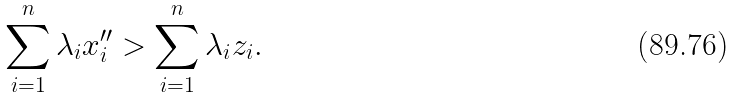<formula> <loc_0><loc_0><loc_500><loc_500>\sum _ { i = 1 } ^ { n } \lambda _ { i } x ^ { \prime \prime } _ { i } & > \sum _ { i = 1 } ^ { n } \lambda _ { i } z _ { i } .</formula> 